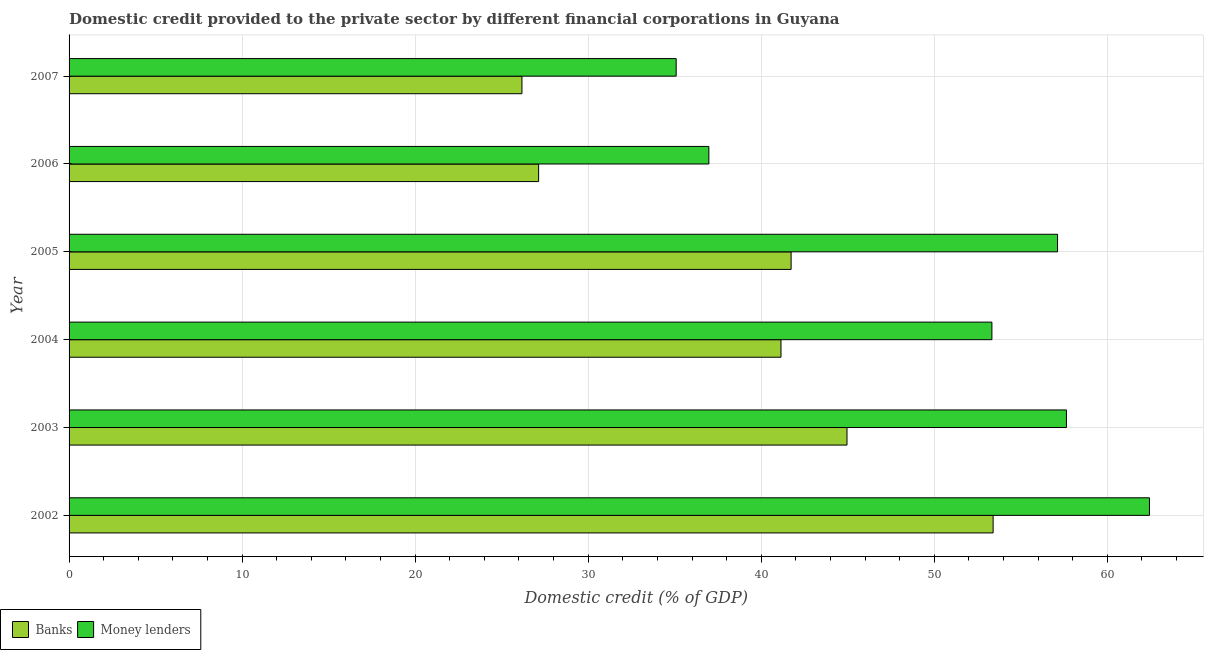How many different coloured bars are there?
Provide a short and direct response. 2. Are the number of bars per tick equal to the number of legend labels?
Ensure brevity in your answer.  Yes. How many bars are there on the 1st tick from the bottom?
Provide a short and direct response. 2. What is the label of the 2nd group of bars from the top?
Your response must be concise. 2006. In how many cases, is the number of bars for a given year not equal to the number of legend labels?
Provide a succinct answer. 0. What is the domestic credit provided by banks in 2004?
Give a very brief answer. 41.14. Across all years, what is the maximum domestic credit provided by banks?
Ensure brevity in your answer.  53.4. Across all years, what is the minimum domestic credit provided by banks?
Your answer should be compact. 26.17. What is the total domestic credit provided by money lenders in the graph?
Offer a very short reply. 302.58. What is the difference between the domestic credit provided by banks in 2003 and that in 2005?
Ensure brevity in your answer.  3.23. What is the difference between the domestic credit provided by money lenders in 2003 and the domestic credit provided by banks in 2006?
Give a very brief answer. 30.5. What is the average domestic credit provided by money lenders per year?
Offer a very short reply. 50.43. In the year 2007, what is the difference between the domestic credit provided by banks and domestic credit provided by money lenders?
Make the answer very short. -8.91. What is the ratio of the domestic credit provided by money lenders in 2002 to that in 2004?
Keep it short and to the point. 1.17. What is the difference between the highest and the second highest domestic credit provided by money lenders?
Your response must be concise. 4.8. What is the difference between the highest and the lowest domestic credit provided by banks?
Provide a succinct answer. 27.23. What does the 2nd bar from the top in 2007 represents?
Provide a short and direct response. Banks. What does the 2nd bar from the bottom in 2003 represents?
Ensure brevity in your answer.  Money lenders. How many bars are there?
Your response must be concise. 12. Are all the bars in the graph horizontal?
Ensure brevity in your answer.  Yes. What is the difference between two consecutive major ticks on the X-axis?
Make the answer very short. 10. Does the graph contain any zero values?
Provide a succinct answer. No. Does the graph contain grids?
Provide a short and direct response. Yes. Where does the legend appear in the graph?
Give a very brief answer. Bottom left. How are the legend labels stacked?
Offer a terse response. Horizontal. What is the title of the graph?
Give a very brief answer. Domestic credit provided to the private sector by different financial corporations in Guyana. Does "Passenger Transport Items" appear as one of the legend labels in the graph?
Your response must be concise. No. What is the label or title of the X-axis?
Make the answer very short. Domestic credit (% of GDP). What is the label or title of the Y-axis?
Ensure brevity in your answer.  Year. What is the Domestic credit (% of GDP) in Banks in 2002?
Your answer should be compact. 53.4. What is the Domestic credit (% of GDP) in Money lenders in 2002?
Make the answer very short. 62.43. What is the Domestic credit (% of GDP) in Banks in 2003?
Make the answer very short. 44.96. What is the Domestic credit (% of GDP) of Money lenders in 2003?
Your response must be concise. 57.64. What is the Domestic credit (% of GDP) of Banks in 2004?
Keep it short and to the point. 41.14. What is the Domestic credit (% of GDP) in Money lenders in 2004?
Make the answer very short. 53.33. What is the Domestic credit (% of GDP) of Banks in 2005?
Provide a short and direct response. 41.73. What is the Domestic credit (% of GDP) of Money lenders in 2005?
Ensure brevity in your answer.  57.12. What is the Domestic credit (% of GDP) in Banks in 2006?
Make the answer very short. 27.14. What is the Domestic credit (% of GDP) of Money lenders in 2006?
Ensure brevity in your answer.  36.97. What is the Domestic credit (% of GDP) in Banks in 2007?
Provide a succinct answer. 26.17. What is the Domestic credit (% of GDP) in Money lenders in 2007?
Make the answer very short. 35.08. Across all years, what is the maximum Domestic credit (% of GDP) of Banks?
Make the answer very short. 53.4. Across all years, what is the maximum Domestic credit (% of GDP) of Money lenders?
Your response must be concise. 62.43. Across all years, what is the minimum Domestic credit (% of GDP) in Banks?
Keep it short and to the point. 26.17. Across all years, what is the minimum Domestic credit (% of GDP) in Money lenders?
Provide a succinct answer. 35.08. What is the total Domestic credit (% of GDP) of Banks in the graph?
Make the answer very short. 234.53. What is the total Domestic credit (% of GDP) in Money lenders in the graph?
Offer a very short reply. 302.58. What is the difference between the Domestic credit (% of GDP) of Banks in 2002 and that in 2003?
Give a very brief answer. 8.44. What is the difference between the Domestic credit (% of GDP) of Money lenders in 2002 and that in 2003?
Provide a succinct answer. 4.8. What is the difference between the Domestic credit (% of GDP) of Banks in 2002 and that in 2004?
Give a very brief answer. 12.26. What is the difference between the Domestic credit (% of GDP) in Money lenders in 2002 and that in 2004?
Offer a terse response. 9.11. What is the difference between the Domestic credit (% of GDP) of Banks in 2002 and that in 2005?
Make the answer very short. 11.67. What is the difference between the Domestic credit (% of GDP) in Money lenders in 2002 and that in 2005?
Provide a short and direct response. 5.31. What is the difference between the Domestic credit (% of GDP) in Banks in 2002 and that in 2006?
Ensure brevity in your answer.  26.26. What is the difference between the Domestic credit (% of GDP) in Money lenders in 2002 and that in 2006?
Ensure brevity in your answer.  25.46. What is the difference between the Domestic credit (% of GDP) in Banks in 2002 and that in 2007?
Your response must be concise. 27.23. What is the difference between the Domestic credit (% of GDP) of Money lenders in 2002 and that in 2007?
Offer a very short reply. 27.35. What is the difference between the Domestic credit (% of GDP) in Banks in 2003 and that in 2004?
Your response must be concise. 3.82. What is the difference between the Domestic credit (% of GDP) of Money lenders in 2003 and that in 2004?
Make the answer very short. 4.31. What is the difference between the Domestic credit (% of GDP) in Banks in 2003 and that in 2005?
Provide a succinct answer. 3.23. What is the difference between the Domestic credit (% of GDP) in Money lenders in 2003 and that in 2005?
Offer a terse response. 0.51. What is the difference between the Domestic credit (% of GDP) of Banks in 2003 and that in 2006?
Provide a short and direct response. 17.82. What is the difference between the Domestic credit (% of GDP) in Money lenders in 2003 and that in 2006?
Make the answer very short. 20.66. What is the difference between the Domestic credit (% of GDP) in Banks in 2003 and that in 2007?
Make the answer very short. 18.78. What is the difference between the Domestic credit (% of GDP) of Money lenders in 2003 and that in 2007?
Your response must be concise. 22.55. What is the difference between the Domestic credit (% of GDP) in Banks in 2004 and that in 2005?
Ensure brevity in your answer.  -0.59. What is the difference between the Domestic credit (% of GDP) in Money lenders in 2004 and that in 2005?
Your response must be concise. -3.79. What is the difference between the Domestic credit (% of GDP) of Banks in 2004 and that in 2006?
Your answer should be compact. 14. What is the difference between the Domestic credit (% of GDP) in Money lenders in 2004 and that in 2006?
Provide a short and direct response. 16.36. What is the difference between the Domestic credit (% of GDP) in Banks in 2004 and that in 2007?
Make the answer very short. 14.97. What is the difference between the Domestic credit (% of GDP) in Money lenders in 2004 and that in 2007?
Keep it short and to the point. 18.25. What is the difference between the Domestic credit (% of GDP) of Banks in 2005 and that in 2006?
Provide a succinct answer. 14.59. What is the difference between the Domestic credit (% of GDP) of Money lenders in 2005 and that in 2006?
Your answer should be very brief. 20.15. What is the difference between the Domestic credit (% of GDP) in Banks in 2005 and that in 2007?
Provide a succinct answer. 15.55. What is the difference between the Domestic credit (% of GDP) in Money lenders in 2005 and that in 2007?
Offer a terse response. 22.04. What is the difference between the Domestic credit (% of GDP) of Banks in 2006 and that in 2007?
Your answer should be very brief. 0.96. What is the difference between the Domestic credit (% of GDP) of Money lenders in 2006 and that in 2007?
Keep it short and to the point. 1.89. What is the difference between the Domestic credit (% of GDP) in Banks in 2002 and the Domestic credit (% of GDP) in Money lenders in 2003?
Ensure brevity in your answer.  -4.24. What is the difference between the Domestic credit (% of GDP) in Banks in 2002 and the Domestic credit (% of GDP) in Money lenders in 2004?
Make the answer very short. 0.07. What is the difference between the Domestic credit (% of GDP) in Banks in 2002 and the Domestic credit (% of GDP) in Money lenders in 2005?
Keep it short and to the point. -3.72. What is the difference between the Domestic credit (% of GDP) of Banks in 2002 and the Domestic credit (% of GDP) of Money lenders in 2006?
Provide a succinct answer. 16.43. What is the difference between the Domestic credit (% of GDP) in Banks in 2002 and the Domestic credit (% of GDP) in Money lenders in 2007?
Provide a succinct answer. 18.32. What is the difference between the Domestic credit (% of GDP) of Banks in 2003 and the Domestic credit (% of GDP) of Money lenders in 2004?
Provide a succinct answer. -8.37. What is the difference between the Domestic credit (% of GDP) in Banks in 2003 and the Domestic credit (% of GDP) in Money lenders in 2005?
Provide a short and direct response. -12.17. What is the difference between the Domestic credit (% of GDP) of Banks in 2003 and the Domestic credit (% of GDP) of Money lenders in 2006?
Your answer should be very brief. 7.98. What is the difference between the Domestic credit (% of GDP) of Banks in 2003 and the Domestic credit (% of GDP) of Money lenders in 2007?
Give a very brief answer. 9.87. What is the difference between the Domestic credit (% of GDP) of Banks in 2004 and the Domestic credit (% of GDP) of Money lenders in 2005?
Provide a succinct answer. -15.98. What is the difference between the Domestic credit (% of GDP) of Banks in 2004 and the Domestic credit (% of GDP) of Money lenders in 2006?
Provide a succinct answer. 4.17. What is the difference between the Domestic credit (% of GDP) of Banks in 2004 and the Domestic credit (% of GDP) of Money lenders in 2007?
Your answer should be very brief. 6.06. What is the difference between the Domestic credit (% of GDP) of Banks in 2005 and the Domestic credit (% of GDP) of Money lenders in 2006?
Your answer should be very brief. 4.75. What is the difference between the Domestic credit (% of GDP) of Banks in 2005 and the Domestic credit (% of GDP) of Money lenders in 2007?
Make the answer very short. 6.64. What is the difference between the Domestic credit (% of GDP) in Banks in 2006 and the Domestic credit (% of GDP) in Money lenders in 2007?
Your response must be concise. -7.95. What is the average Domestic credit (% of GDP) of Banks per year?
Your response must be concise. 39.09. What is the average Domestic credit (% of GDP) in Money lenders per year?
Offer a terse response. 50.43. In the year 2002, what is the difference between the Domestic credit (% of GDP) in Banks and Domestic credit (% of GDP) in Money lenders?
Offer a terse response. -9.03. In the year 2003, what is the difference between the Domestic credit (% of GDP) of Banks and Domestic credit (% of GDP) of Money lenders?
Give a very brief answer. -12.68. In the year 2004, what is the difference between the Domestic credit (% of GDP) in Banks and Domestic credit (% of GDP) in Money lenders?
Ensure brevity in your answer.  -12.19. In the year 2005, what is the difference between the Domestic credit (% of GDP) in Banks and Domestic credit (% of GDP) in Money lenders?
Make the answer very short. -15.4. In the year 2006, what is the difference between the Domestic credit (% of GDP) of Banks and Domestic credit (% of GDP) of Money lenders?
Give a very brief answer. -9.84. In the year 2007, what is the difference between the Domestic credit (% of GDP) of Banks and Domestic credit (% of GDP) of Money lenders?
Offer a very short reply. -8.91. What is the ratio of the Domestic credit (% of GDP) of Banks in 2002 to that in 2003?
Provide a short and direct response. 1.19. What is the ratio of the Domestic credit (% of GDP) of Banks in 2002 to that in 2004?
Your answer should be very brief. 1.3. What is the ratio of the Domestic credit (% of GDP) in Money lenders in 2002 to that in 2004?
Give a very brief answer. 1.17. What is the ratio of the Domestic credit (% of GDP) in Banks in 2002 to that in 2005?
Give a very brief answer. 1.28. What is the ratio of the Domestic credit (% of GDP) in Money lenders in 2002 to that in 2005?
Ensure brevity in your answer.  1.09. What is the ratio of the Domestic credit (% of GDP) in Banks in 2002 to that in 2006?
Your response must be concise. 1.97. What is the ratio of the Domestic credit (% of GDP) in Money lenders in 2002 to that in 2006?
Provide a succinct answer. 1.69. What is the ratio of the Domestic credit (% of GDP) of Banks in 2002 to that in 2007?
Keep it short and to the point. 2.04. What is the ratio of the Domestic credit (% of GDP) in Money lenders in 2002 to that in 2007?
Give a very brief answer. 1.78. What is the ratio of the Domestic credit (% of GDP) of Banks in 2003 to that in 2004?
Offer a terse response. 1.09. What is the ratio of the Domestic credit (% of GDP) in Money lenders in 2003 to that in 2004?
Offer a terse response. 1.08. What is the ratio of the Domestic credit (% of GDP) of Banks in 2003 to that in 2005?
Your answer should be very brief. 1.08. What is the ratio of the Domestic credit (% of GDP) in Banks in 2003 to that in 2006?
Provide a short and direct response. 1.66. What is the ratio of the Domestic credit (% of GDP) in Money lenders in 2003 to that in 2006?
Ensure brevity in your answer.  1.56. What is the ratio of the Domestic credit (% of GDP) in Banks in 2003 to that in 2007?
Your response must be concise. 1.72. What is the ratio of the Domestic credit (% of GDP) in Money lenders in 2003 to that in 2007?
Provide a succinct answer. 1.64. What is the ratio of the Domestic credit (% of GDP) in Banks in 2004 to that in 2005?
Ensure brevity in your answer.  0.99. What is the ratio of the Domestic credit (% of GDP) in Money lenders in 2004 to that in 2005?
Your response must be concise. 0.93. What is the ratio of the Domestic credit (% of GDP) of Banks in 2004 to that in 2006?
Ensure brevity in your answer.  1.52. What is the ratio of the Domestic credit (% of GDP) of Money lenders in 2004 to that in 2006?
Keep it short and to the point. 1.44. What is the ratio of the Domestic credit (% of GDP) in Banks in 2004 to that in 2007?
Ensure brevity in your answer.  1.57. What is the ratio of the Domestic credit (% of GDP) in Money lenders in 2004 to that in 2007?
Your answer should be very brief. 1.52. What is the ratio of the Domestic credit (% of GDP) in Banks in 2005 to that in 2006?
Ensure brevity in your answer.  1.54. What is the ratio of the Domestic credit (% of GDP) in Money lenders in 2005 to that in 2006?
Provide a short and direct response. 1.54. What is the ratio of the Domestic credit (% of GDP) in Banks in 2005 to that in 2007?
Provide a short and direct response. 1.59. What is the ratio of the Domestic credit (% of GDP) of Money lenders in 2005 to that in 2007?
Keep it short and to the point. 1.63. What is the ratio of the Domestic credit (% of GDP) of Banks in 2006 to that in 2007?
Make the answer very short. 1.04. What is the ratio of the Domestic credit (% of GDP) of Money lenders in 2006 to that in 2007?
Ensure brevity in your answer.  1.05. What is the difference between the highest and the second highest Domestic credit (% of GDP) of Banks?
Give a very brief answer. 8.44. What is the difference between the highest and the second highest Domestic credit (% of GDP) of Money lenders?
Keep it short and to the point. 4.8. What is the difference between the highest and the lowest Domestic credit (% of GDP) in Banks?
Offer a terse response. 27.23. What is the difference between the highest and the lowest Domestic credit (% of GDP) in Money lenders?
Your answer should be very brief. 27.35. 